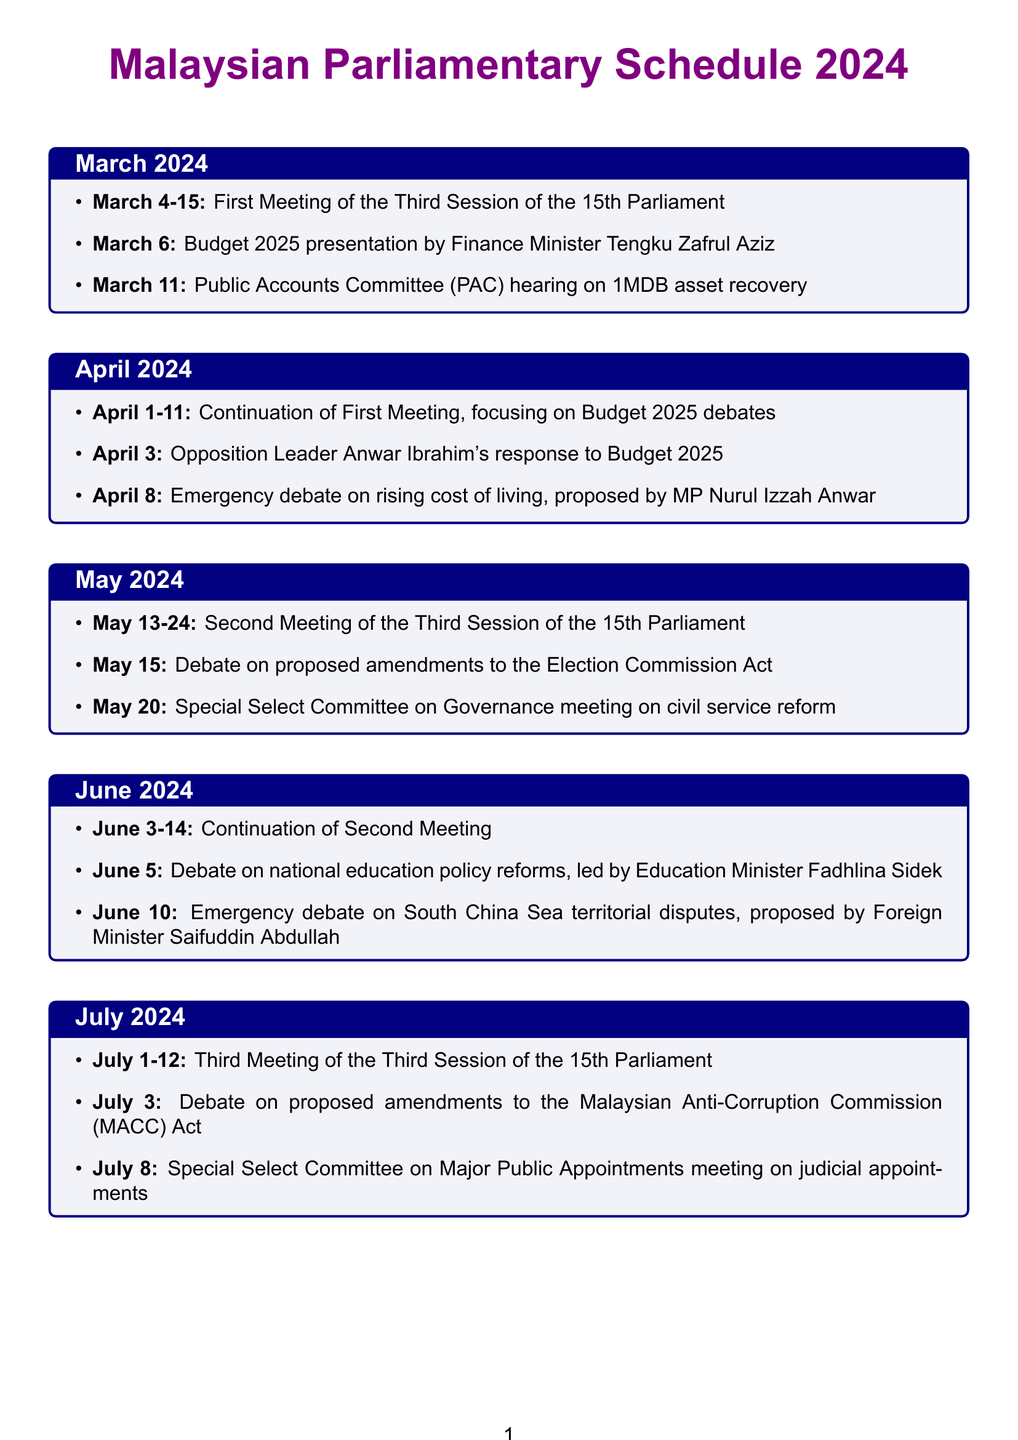what is the date of the first parliamentary session in March 2024? The first parliamentary session runs from March 4 to March 15, 2024.
Answer: March 4-15 who presented the Budget 2025 in March 2024? The Budget 2025 was presented by Finance Minister Tengku Zafrul Aziz.
Answer: Tengku Zafrul Aziz what is the topic of the emergency debate proposed by MP Nurul Izzah Anwar in April 2024? The emergency debate is on the rising cost of living.
Answer: rising cost of living how many key debates are scheduled in May 2024? There are two key debates scheduled in May 2024, one on amendments to the Election Commission Act and another on civil service reform.
Answer: 2 what is the focus of the parliamentary session from June 3-14, 2024? The focus is on the continuation of the Second Meeting.
Answer: continuation of the Second Meeting who leads the debate on national education policy reforms in June 2024? Education Minister Fadhlina Sidek leads the debate on national education policy reforms.
Answer: Fadhlina Sidek when is the third parliamentary session scheduled to start in July 2024? The third parliamentary session starts on July 1, 2024.
Answer: July 1 what significant topic will be discussed on July 3, 2024? The significant topic is proposed amendments to the Malaysian Anti-Corruption Commission (MACC) Act.
Answer: proposed amendments to the Malaysian Anti-Corruption Commission (MACC) Act when is the hearing on 1MDB asset recovery scheduled? The hearing on 1MDB asset recovery is scheduled for March 11, 2024.
Answer: March 11 